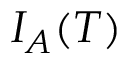Convert formula to latex. <formula><loc_0><loc_0><loc_500><loc_500>I _ { A } ( T )</formula> 